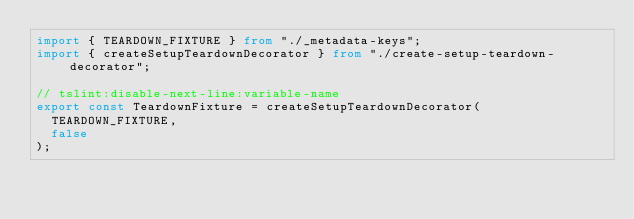Convert code to text. <code><loc_0><loc_0><loc_500><loc_500><_TypeScript_>import { TEARDOWN_FIXTURE } from "./_metadata-keys";
import { createSetupTeardownDecorator } from "./create-setup-teardown-decorator";

// tslint:disable-next-line:variable-name
export const TeardownFixture = createSetupTeardownDecorator(
	TEARDOWN_FIXTURE,
	false
);
</code> 